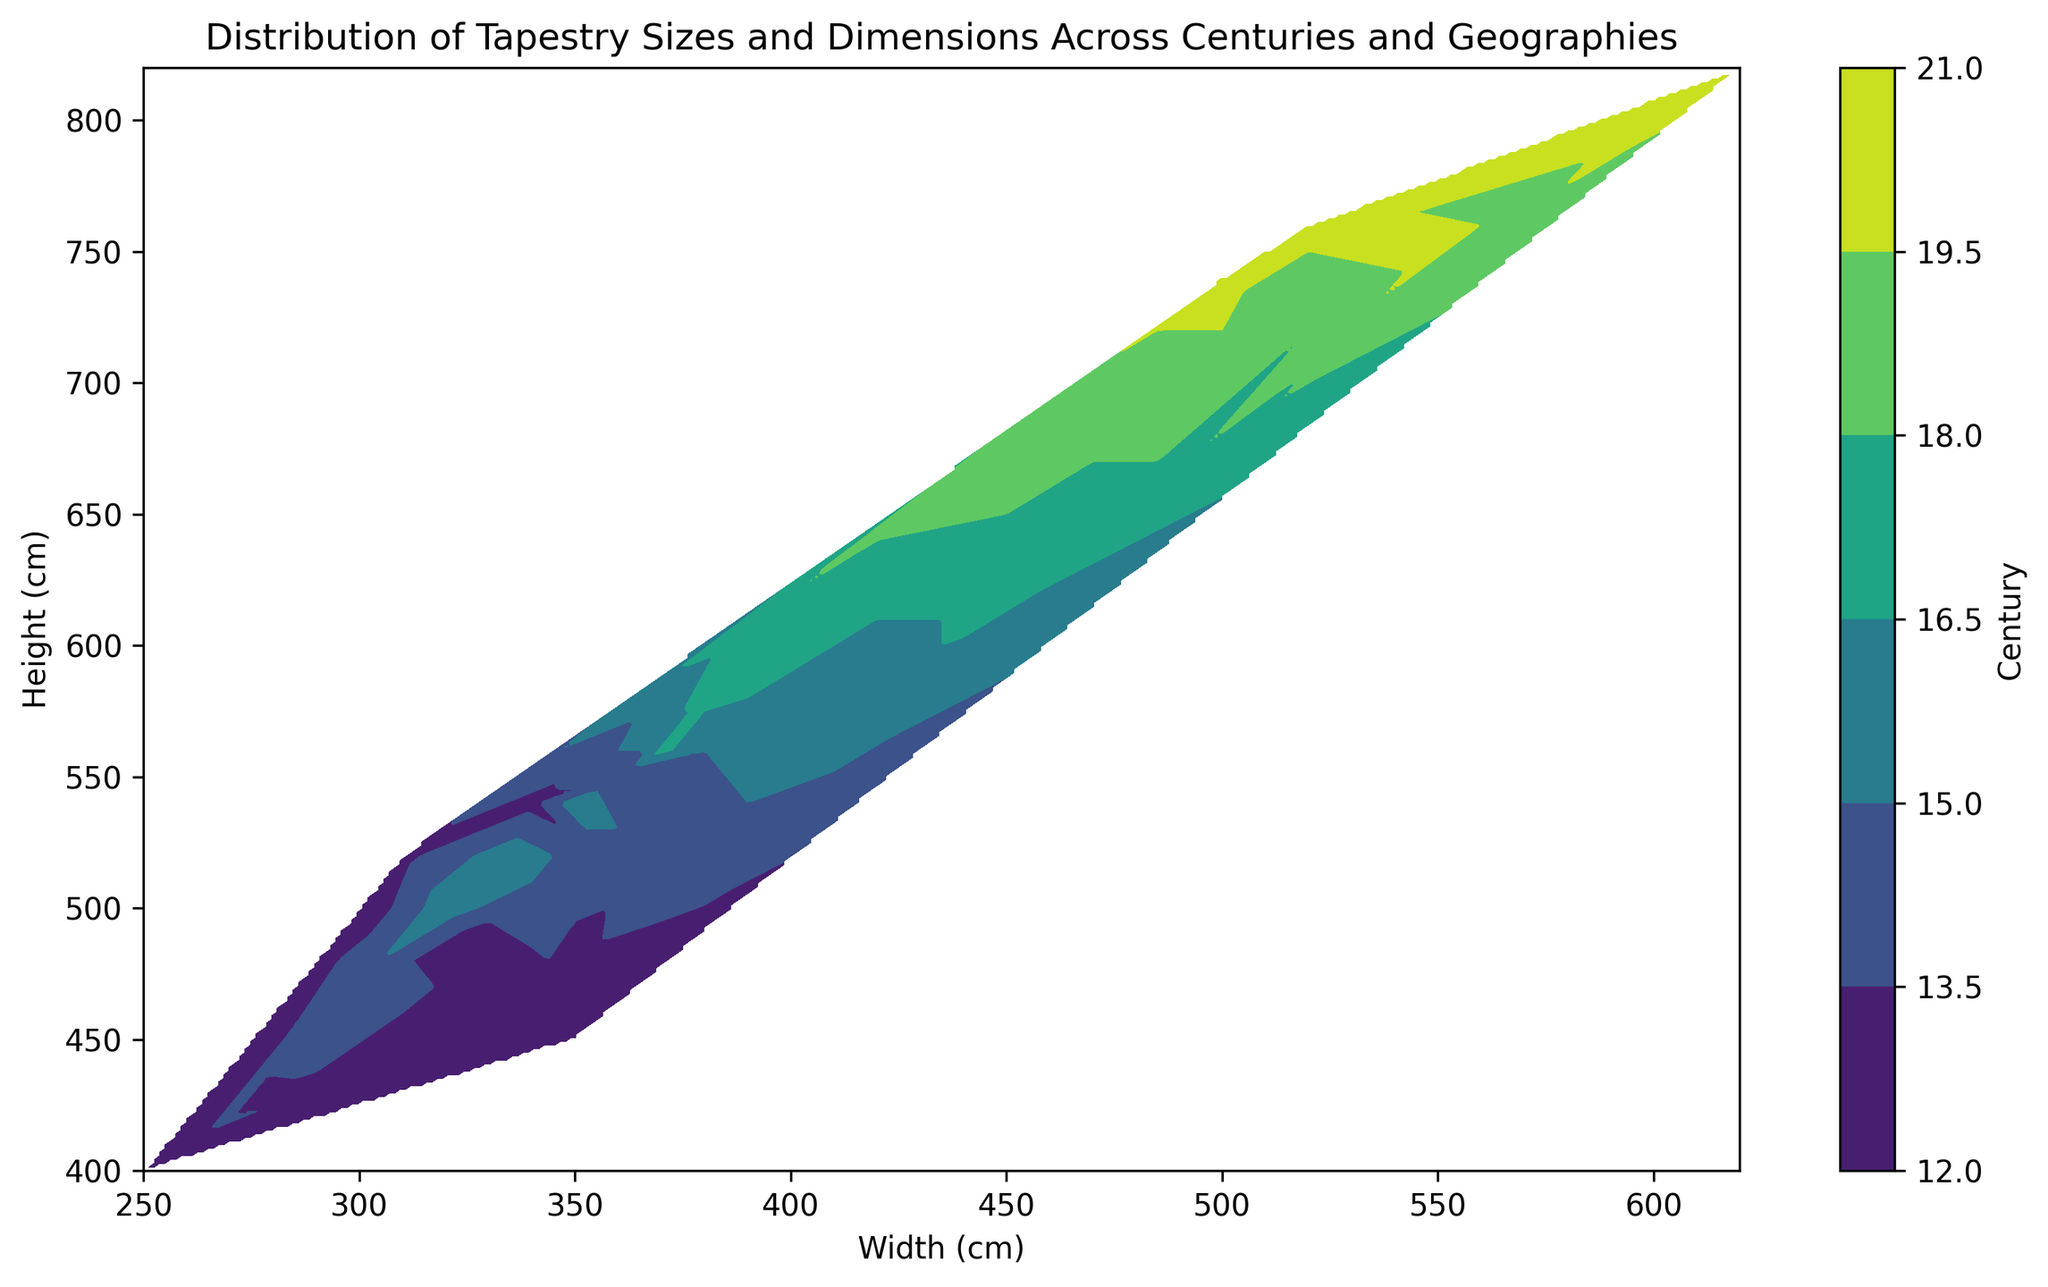What general trend can be observed in the tapestry sizes over the centuries? As the century progresses from the 12th to the 20th century, the tapestries generally increase in size. This can be observed by noting that the earlier centuries are represented by smaller widths and heights, and the later centuries are generally positioned at higher widths and heights in the contour plot.
Answer: Tapestries generally increase in size over the centuries Which century has the widest range of tapestry dimensions? By examining the contour plot, the century with the widest range of tapestry dimensions has the greatest variation in both width and height. The 20th century shows a significant spread in both width and height, reaching maximum values compared to other centuries.
Answer: 20th century How do the tapestry sizes from Italy compare to those from France? Within the contour plot, observing the dimensions that correlate with earlier centuries (lower color values) and noting the general size distribution over centuries, tapestries from Italy gradually increase from smaller to larger sizes. Similarly, France exhibits the same increasing trend, but French tapestries tend to become larger earlier than Italian ones.
Answer: French tapestries tend to be larger earlier than Italian ones During which centuries do the tapestry sizes remain relatively unchanged? Given the smooth color gradients and similar dimensional values over specific centuries, there appear to be less drastic changes between the 13th and the 16th centuries. This is indicated by relatively similar spatial locations and color bands within those centuries.
Answer: 13th to 16th centuries What is the largest dimension of tapestries in the 18th century? By noting the color corresponding to the 18th century and its positioning on the plot, the largest width and height values reach around 520 cm and 720 cm, respectively.
Answer: 520 cm by 720 cm How does the complexity of tapestry size distribution compare between the 14th and 17th centuries? Comparing the 14th and 17th centuries within the contour plot, observe the gradient and spread of colors. The 17th century has a more complex and broader spread of sizes indicated by a larger and more diffuse region in the contour plot compared to the relatively smaller range of the 14th century.
Answer: 17th century has a more complex size distribution What is the primary difference in tapestry dimension trends between England and France? Observing the color bands associated with English and French geographic plots, French tapestries exhibit a consistent, gradual increase in dimension sizes, while English tapestries display more gradual and smaller increments. France’s tapestries overall achieve larger dimensions earlier than those from England.
Answer: French tapestries achieve larger dimensions earlier 